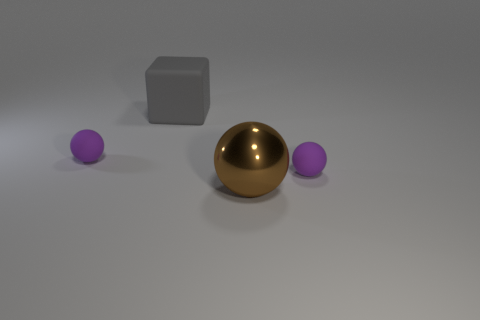Add 1 tiny purple matte balls. How many objects exist? 5 Subtract all blocks. How many objects are left? 3 Add 3 small purple spheres. How many small purple spheres are left? 5 Add 3 small purple matte things. How many small purple matte things exist? 5 Subtract 0 cyan cylinders. How many objects are left? 4 Subtract all brown shiny spheres. Subtract all red matte spheres. How many objects are left? 3 